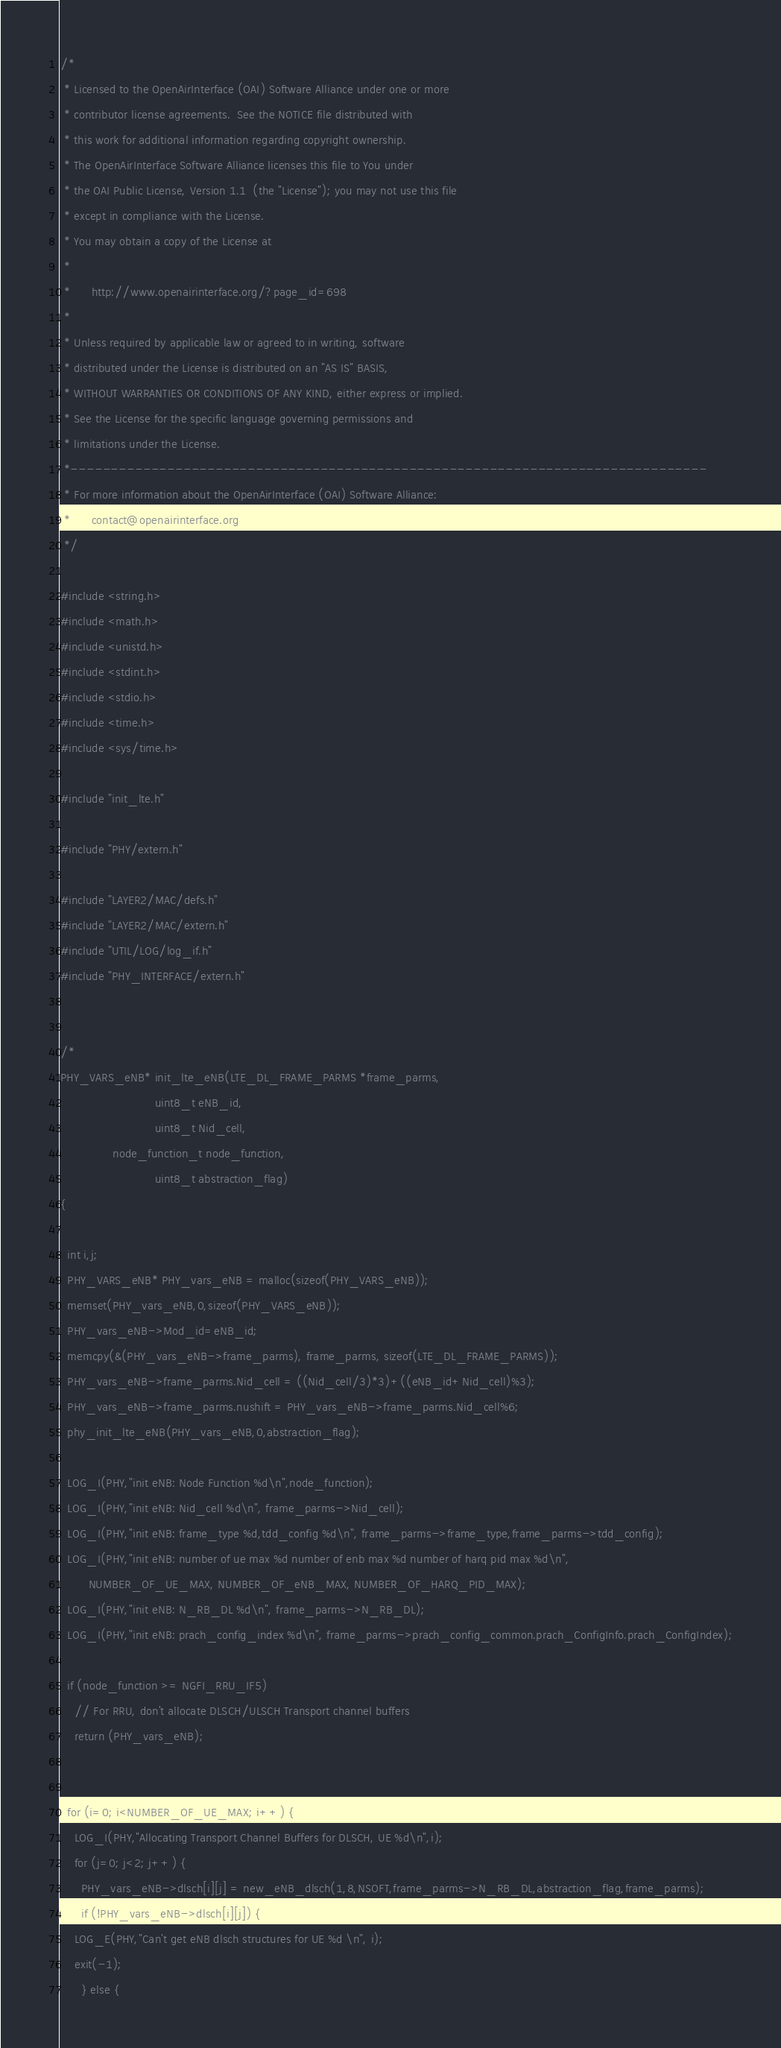Convert code to text. <code><loc_0><loc_0><loc_500><loc_500><_C_>/*
 * Licensed to the OpenAirInterface (OAI) Software Alliance under one or more
 * contributor license agreements.  See the NOTICE file distributed with
 * this work for additional information regarding copyright ownership.
 * The OpenAirInterface Software Alliance licenses this file to You under
 * the OAI Public License, Version 1.1  (the "License"); you may not use this file
 * except in compliance with the License.
 * You may obtain a copy of the License at
 *
 *      http://www.openairinterface.org/?page_id=698
 *
 * Unless required by applicable law or agreed to in writing, software
 * distributed under the License is distributed on an "AS IS" BASIS,
 * WITHOUT WARRANTIES OR CONDITIONS OF ANY KIND, either express or implied.
 * See the License for the specific language governing permissions and
 * limitations under the License.
 *-------------------------------------------------------------------------------
 * For more information about the OpenAirInterface (OAI) Software Alliance:
 *      contact@openairinterface.org
 */

#include <string.h>
#include <math.h>
#include <unistd.h>
#include <stdint.h>
#include <stdio.h>
#include <time.h>
#include <sys/time.h>

#include "init_lte.h"

#include "PHY/extern.h"

#include "LAYER2/MAC/defs.h"
#include "LAYER2/MAC/extern.h"
#include "UTIL/LOG/log_if.h"
#include "PHY_INTERFACE/extern.h"


/*
PHY_VARS_eNB* init_lte_eNB(LTE_DL_FRAME_PARMS *frame_parms,
                           uint8_t eNB_id,
                           uint8_t Nid_cell,
			   node_function_t node_function,
                           uint8_t abstraction_flag)
{

  int i,j;
  PHY_VARS_eNB* PHY_vars_eNB = malloc(sizeof(PHY_VARS_eNB));
  memset(PHY_vars_eNB,0,sizeof(PHY_VARS_eNB));
  PHY_vars_eNB->Mod_id=eNB_id;
  memcpy(&(PHY_vars_eNB->frame_parms), frame_parms, sizeof(LTE_DL_FRAME_PARMS));
  PHY_vars_eNB->frame_parms.Nid_cell = ((Nid_cell/3)*3)+((eNB_id+Nid_cell)%3);
  PHY_vars_eNB->frame_parms.nushift = PHY_vars_eNB->frame_parms.Nid_cell%6;
  phy_init_lte_eNB(PHY_vars_eNB,0,abstraction_flag);

  LOG_I(PHY,"init eNB: Node Function %d\n",node_function);
  LOG_I(PHY,"init eNB: Nid_cell %d\n", frame_parms->Nid_cell);
  LOG_I(PHY,"init eNB: frame_type %d,tdd_config %d\n", frame_parms->frame_type,frame_parms->tdd_config);
  LOG_I(PHY,"init eNB: number of ue max %d number of enb max %d number of harq pid max %d\n",
        NUMBER_OF_UE_MAX, NUMBER_OF_eNB_MAX, NUMBER_OF_HARQ_PID_MAX);
  LOG_I(PHY,"init eNB: N_RB_DL %d\n", frame_parms->N_RB_DL);
  LOG_I(PHY,"init eNB: prach_config_index %d\n", frame_parms->prach_config_common.prach_ConfigInfo.prach_ConfigIndex);

  if (node_function >= NGFI_RRU_IF5)
    // For RRU, don't allocate DLSCH/ULSCH Transport channel buffers
    return (PHY_vars_eNB);


  for (i=0; i<NUMBER_OF_UE_MAX; i++) {
    LOG_I(PHY,"Allocating Transport Channel Buffers for DLSCH, UE %d\n",i);
    for (j=0; j<2; j++) {
      PHY_vars_eNB->dlsch[i][j] = new_eNB_dlsch(1,8,NSOFT,frame_parms->N_RB_DL,abstraction_flag,frame_parms);
      if (!PHY_vars_eNB->dlsch[i][j]) {
	LOG_E(PHY,"Can't get eNB dlsch structures for UE %d \n", i);
	exit(-1);
      } else {</code> 